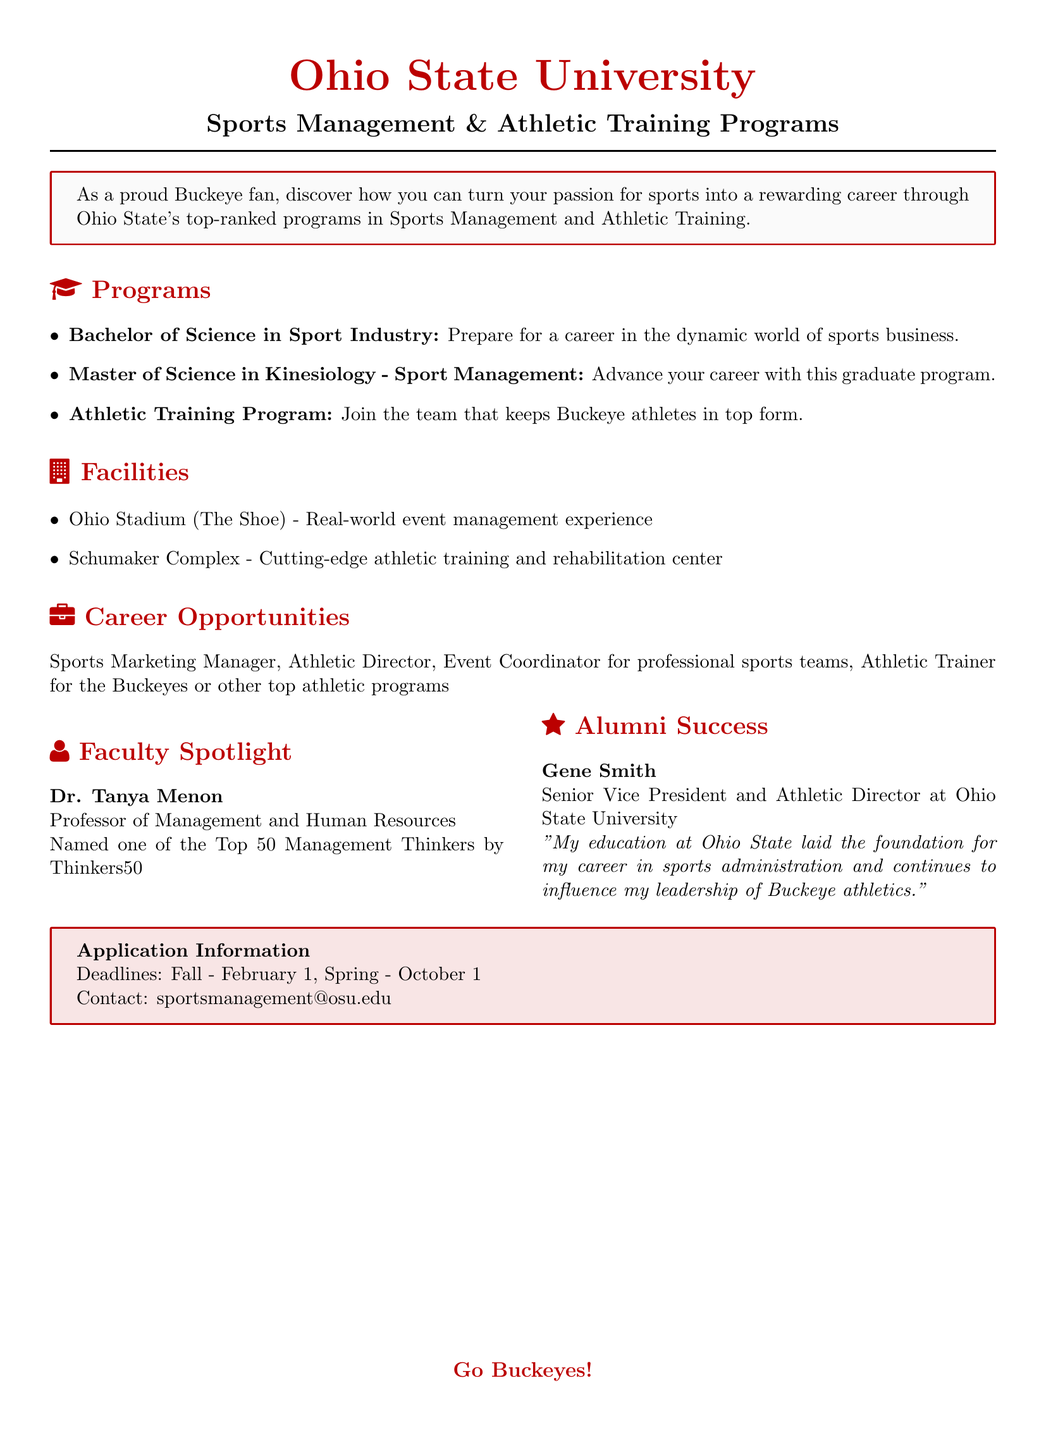What is the title of the document? The title of the document is presented at the top, which is "Ohio State University Sports Management & Athletic Training Programs."
Answer: Ohio State University Sports Management & Athletic Training Programs How many programs are listed under Programs? The document lists three distinct programs under the Programs section.
Answer: 3 Who is the faculty spotlight featured in the document? The faculty spotlight highlights Dr. Tanya Menon as the featured faculty member.
Answer: Dr. Tanya Menon What is the application deadline for Fall? The document specifies the application deadline for the Fall term as February 1.
Answer: February 1 What type of program is the Athletic Training Program? The document categorizes the Athletic Training Program as a program that allows students to join the team that supports Buckeye athletes.
Answer: Athletic Training Program Which facility is mentioned for real-world event management experience? The document refers to Ohio Stadium (The Shoe) as the facility for real-world event management experience.
Answer: Ohio Stadium (The Shoe) Who is the notable alumnus mentioned in the document? The document names Gene Smith as the notable alumnus in the Alumni Success section.
Answer: Gene Smith What role does Gene Smith hold? According to the document, Gene Smith is the Senior Vice President and Athletic Director at Ohio State University.
Answer: Senior Vice President and Athletic Director What is the contact email for the sports management program? The document provides a contact email for inquiries about the sports management program, which is listed clearly in the Application Information section.
Answer: sportsmanagement@osu.edu 